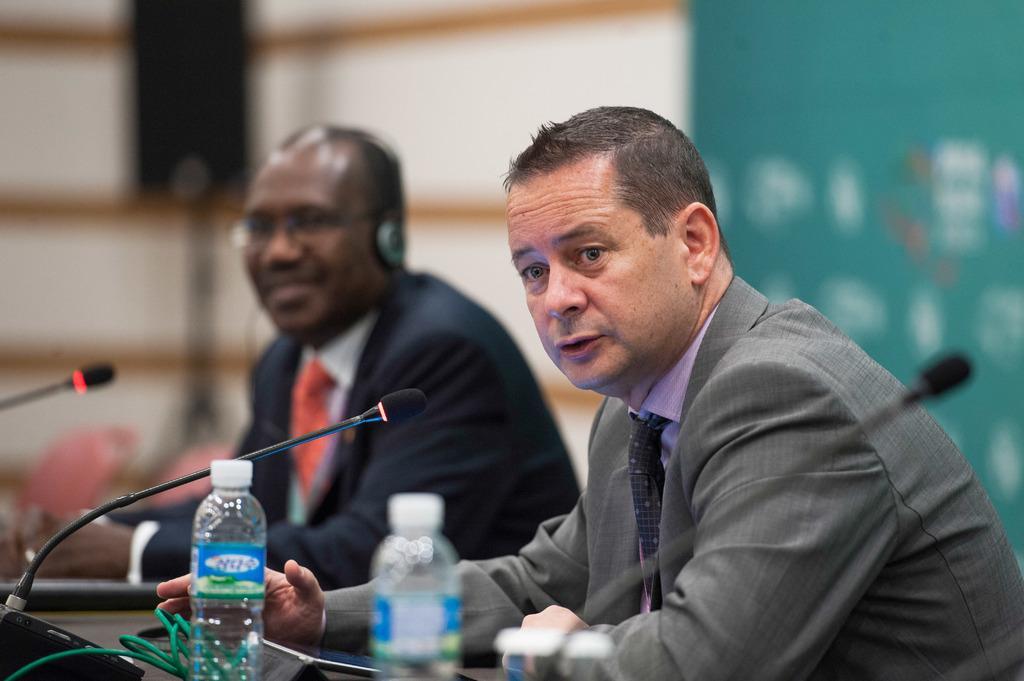Can you describe this image briefly? 2 people are seated wearing suit. in front of them there is a table on which there are bottles and microphones. 